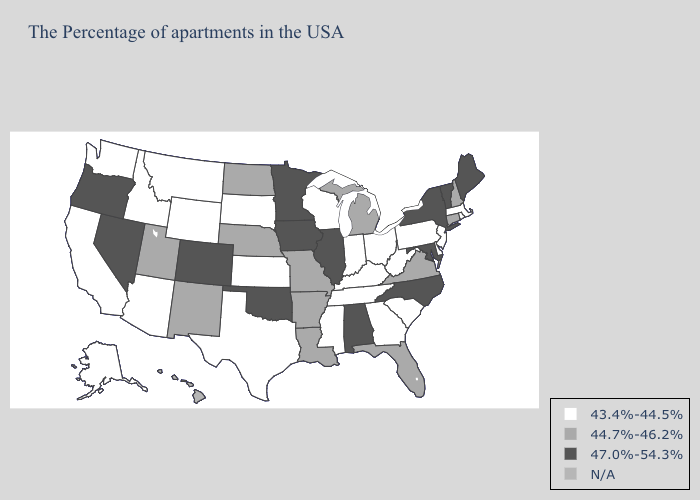Among the states that border Arizona , which have the lowest value?
Be succinct. California. Name the states that have a value in the range 47.0%-54.3%?
Quick response, please. Maine, Vermont, New York, Maryland, North Carolina, Alabama, Illinois, Minnesota, Iowa, Oklahoma, Colorado, Nevada, Oregon. Name the states that have a value in the range 43.4%-44.5%?
Answer briefly. Massachusetts, Rhode Island, New Jersey, Delaware, Pennsylvania, South Carolina, West Virginia, Ohio, Georgia, Kentucky, Indiana, Tennessee, Wisconsin, Mississippi, Kansas, Texas, South Dakota, Wyoming, Montana, Arizona, Idaho, California, Washington, Alaska. Does Virginia have the lowest value in the South?
Keep it brief. No. Does Louisiana have the lowest value in the South?
Quick response, please. No. Is the legend a continuous bar?
Answer briefly. No. What is the lowest value in the USA?
Answer briefly. 43.4%-44.5%. What is the lowest value in states that border Kansas?
Short answer required. 44.7%-46.2%. Name the states that have a value in the range 47.0%-54.3%?
Write a very short answer. Maine, Vermont, New York, Maryland, North Carolina, Alabama, Illinois, Minnesota, Iowa, Oklahoma, Colorado, Nevada, Oregon. Does the first symbol in the legend represent the smallest category?
Short answer required. Yes. What is the value of Washington?
Concise answer only. 43.4%-44.5%. What is the lowest value in states that border Mississippi?
Concise answer only. 43.4%-44.5%. Does Nevada have the lowest value in the West?
Concise answer only. No. What is the value of New Mexico?
Be succinct. 44.7%-46.2%. 